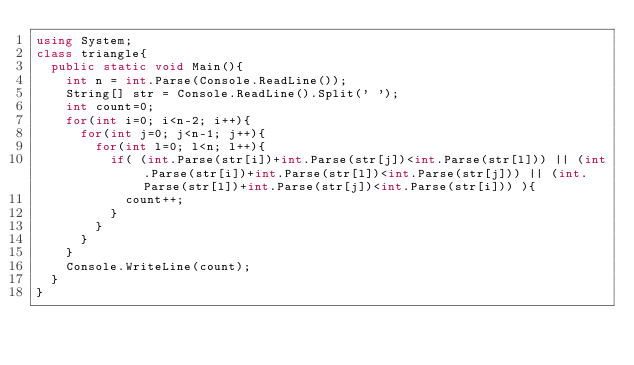Convert code to text. <code><loc_0><loc_0><loc_500><loc_500><_C#_>using System;
class triangle{
  public static void Main(){
    int n = int.Parse(Console.ReadLine());
    String[] str = Console.ReadLine().Split(' ');
    int count=0;
    for(int i=0; i<n-2; i++){
      for(int j=0; j<n-1; j++){
        for(int l=0; l<n; l++){
          if( (int.Parse(str[i])+int.Parse(str[j])<int.Parse(str[l])) || (int.Parse(str[i])+int.Parse(str[l])<int.Parse(str[j])) || (int.Parse(str[l])+int.Parse(str[j])<int.Parse(str[i])) ){
            count++;
          }
        }
      }
    }
    Console.WriteLine(count);
  }
}
</code> 